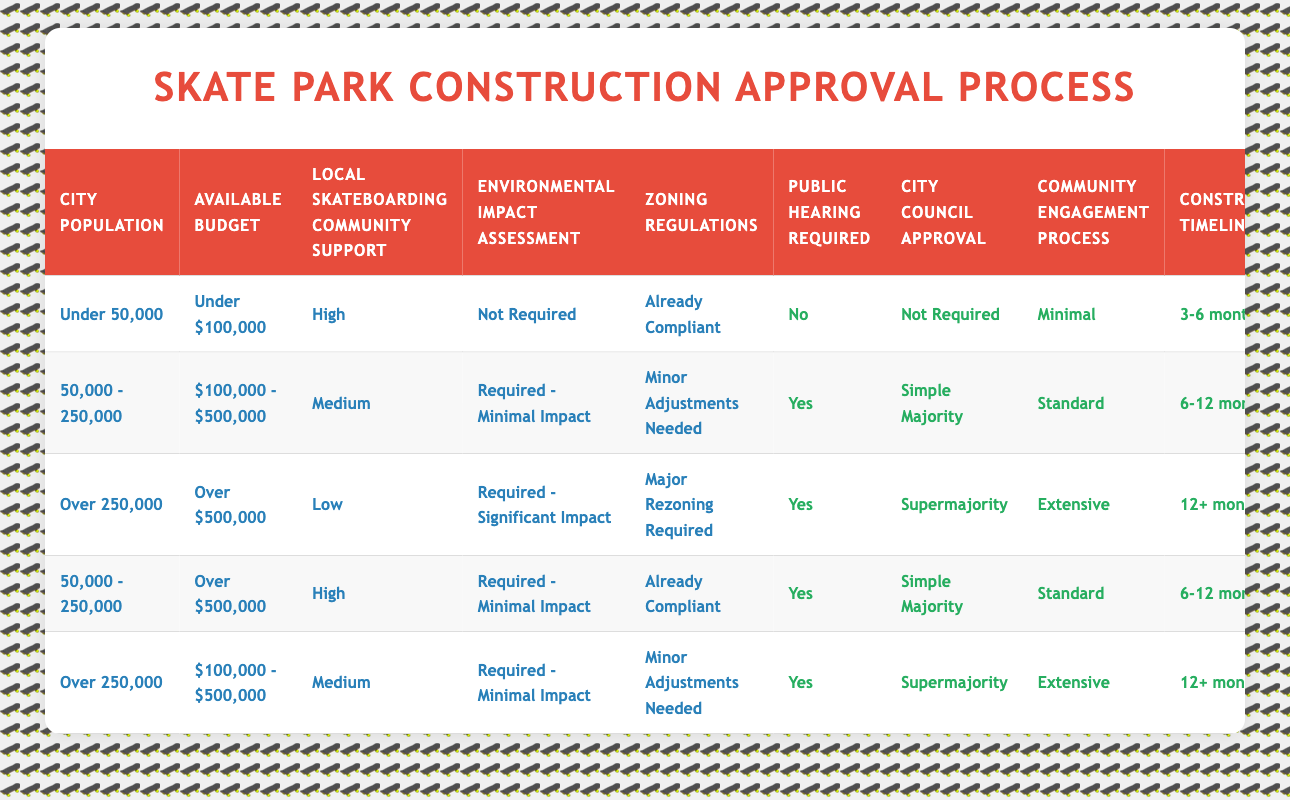What is the construction timeline for a skate park in a city with a population of 50,000 to 250,000 and a budget of over $500,000? In the table, we look for the row where the city population is "50,000 - 250,000" and the available budget is "Over $500,000." Only one row matches these conditions, which states the construction timeline is "6-12 months."
Answer: 6-12 months Is a public hearing required for a skate park if the city population is over 250,000 and the available budget is under $100,000? We can check the table for the conditions mentioned: "Over 250,000" for city population and "Under $100,000" for the budget. There are no rows that meet both conditions simultaneously, indicating that a public hearing would not be required as there are no applicable scenarios.
Answer: No What is the average construction timeline for all cases where community engagement is extensive? We first identify the rows where "Community Engagement Process" is "Extensive." In the table, there are two such cases, both with "Construction Timeline" of "12+ months." To find the average, we consider converting this to a numerical system, where 12+ months is interpreted as 12 months (the lowest value). Thus, the average construction timeline is (12 + 12) / 2 = 12 months.
Answer: 12 months Does having high local skateboarding community support affect the requirement for city council approval if the population is under 50,000? We find the table rows for "Under 50,000" population and "High" local support, which has one matching scenario with "City Council Approval" status of "Not Required." Therefore, for such conditions, a city council approval is not required when the local support is high.
Answer: Yes For a city with a population over 250,000, what are the sponsorship opportunities if the budget is over $500,000 and community support is low? Checking the rows for "Over 250,000" population, "Over $500,000" budget, and "Low" community support gives us only one matching scenario. This case shows "Sponsorship Opportunities" as "Extensive." Therefore, in this scenario, there would be extensive sponsorship opportunities.
Answer: Extensive 